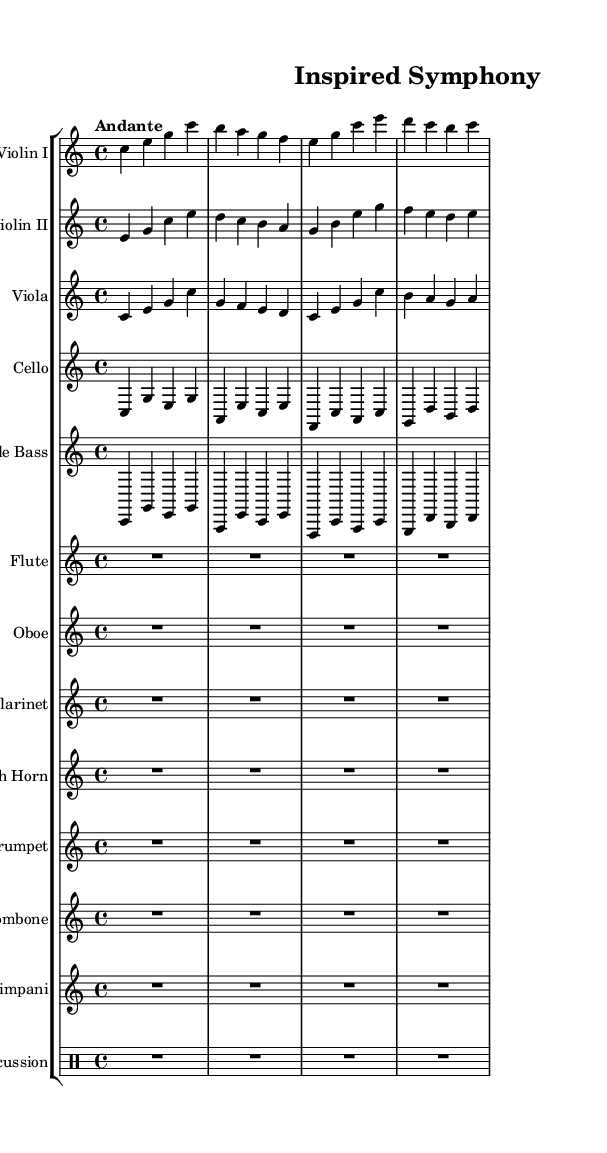What is the key signature of this music? The key signature at the beginning indicates C major, which has no sharps or flats. This can be identified by looking for the key signature symbols at the start of the staff.
Answer: C major What is the time signature of this music? The time signature is shown at the beginning of the music and is indicated as 4/4, meaning there are four beats in a measure and the quarter note gets one beat.
Answer: 4/4 What is the tempo marking for this piece? The tempo marking is found in the header section and is described as "Andante," which typically indicates a moderate walking speed.
Answer: Andante How many different string instrument parts are included in this score? By counting the individual staves, there are a total of five string instruments: Violin I, Violin II, Viola, Cello, and Double Bass.
Answer: Five Which instruments have rests for the entire duration of the piece? The instruments Flute, Oboe, Clarinet, French Horn, Trumpet, Trombone, Timpani, and Percussion are marked with R1*4 for their entire measure, indicating rests for the whole bar.
Answer: Flute, Oboe, Clarinet, French Horn, Trumpet, Trombone, Timpani, Percussion What is the range of notes for the Violin I part? The Violin I part starts on a C and includes notes up to a higher C, demonstrating a range typically associated with the violin that spans over an octave.
Answer: C to C 